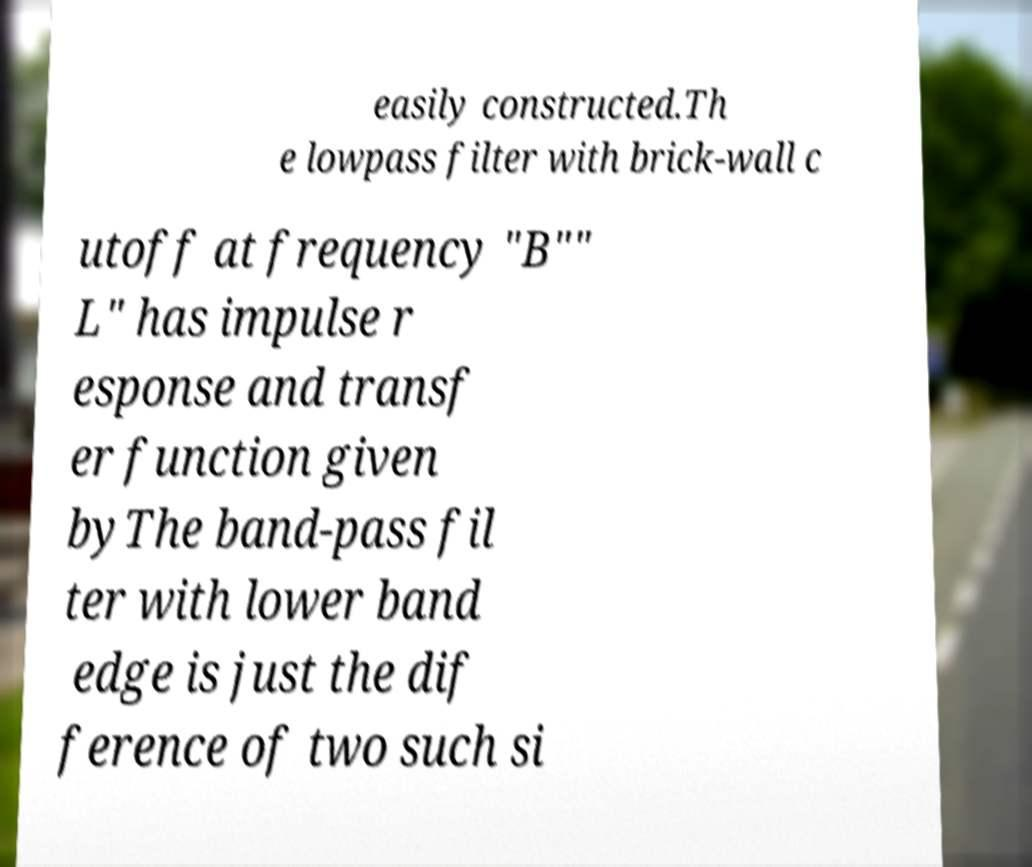Can you accurately transcribe the text from the provided image for me? easily constructed.Th e lowpass filter with brick-wall c utoff at frequency "B"" L" has impulse r esponse and transf er function given byThe band-pass fil ter with lower band edge is just the dif ference of two such si 